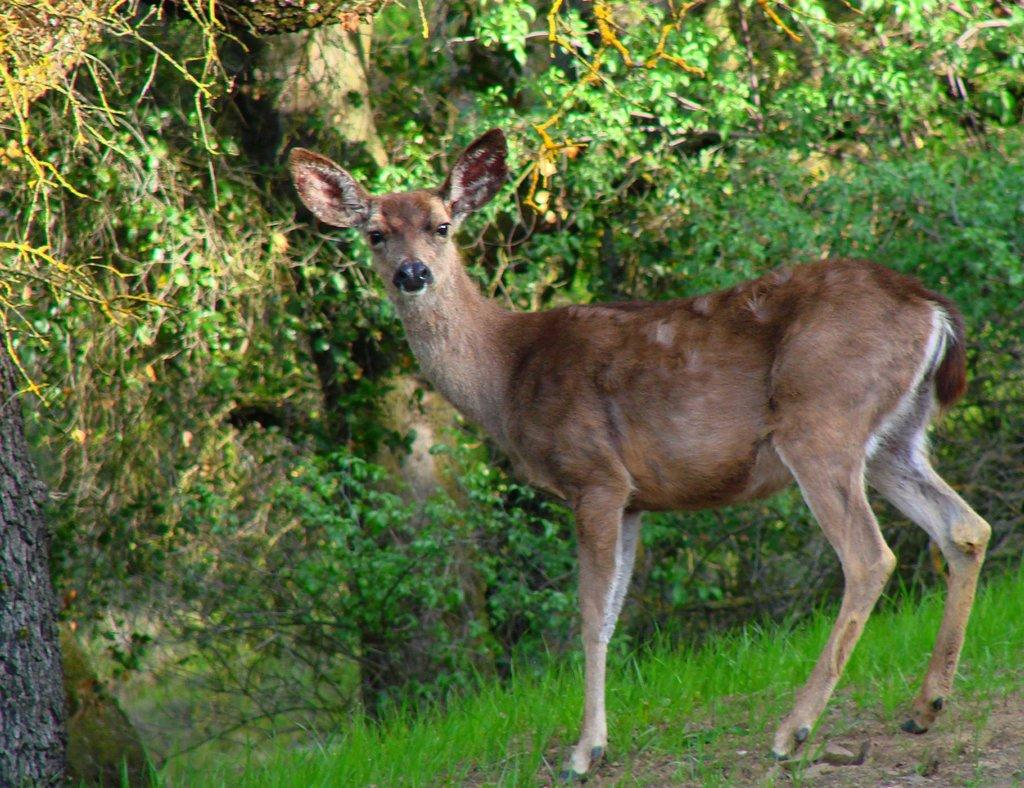What type of animal can be seen in the image? There is a deer in the image. What type of vegetation is present in the image? There is grass and plants in the image. Can you describe the tree in the image? There is a tree on the left side of the image. What type of cat can be seen climbing the tree in the image? There is no cat present in the image; it only features a deer, grass, plants, and a tree. 